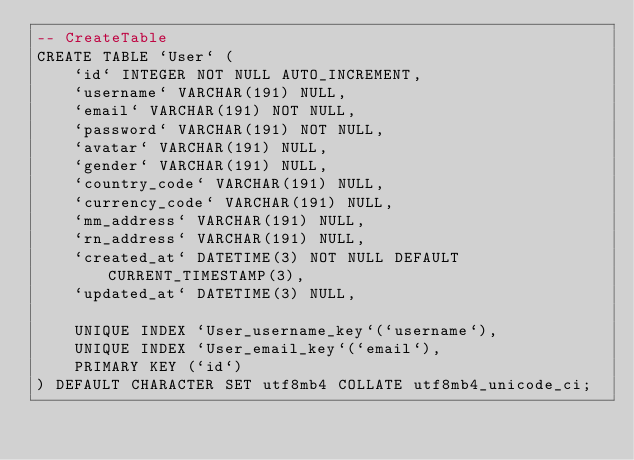Convert code to text. <code><loc_0><loc_0><loc_500><loc_500><_SQL_>-- CreateTable
CREATE TABLE `User` (
    `id` INTEGER NOT NULL AUTO_INCREMENT,
    `username` VARCHAR(191) NULL,
    `email` VARCHAR(191) NOT NULL,
    `password` VARCHAR(191) NOT NULL,
    `avatar` VARCHAR(191) NULL,
    `gender` VARCHAR(191) NULL,
    `country_code` VARCHAR(191) NULL,
    `currency_code` VARCHAR(191) NULL,
    `mm_address` VARCHAR(191) NULL,
    `rn_address` VARCHAR(191) NULL,
    `created_at` DATETIME(3) NOT NULL DEFAULT CURRENT_TIMESTAMP(3),
    `updated_at` DATETIME(3) NULL,

    UNIQUE INDEX `User_username_key`(`username`),
    UNIQUE INDEX `User_email_key`(`email`),
    PRIMARY KEY (`id`)
) DEFAULT CHARACTER SET utf8mb4 COLLATE utf8mb4_unicode_ci;
</code> 